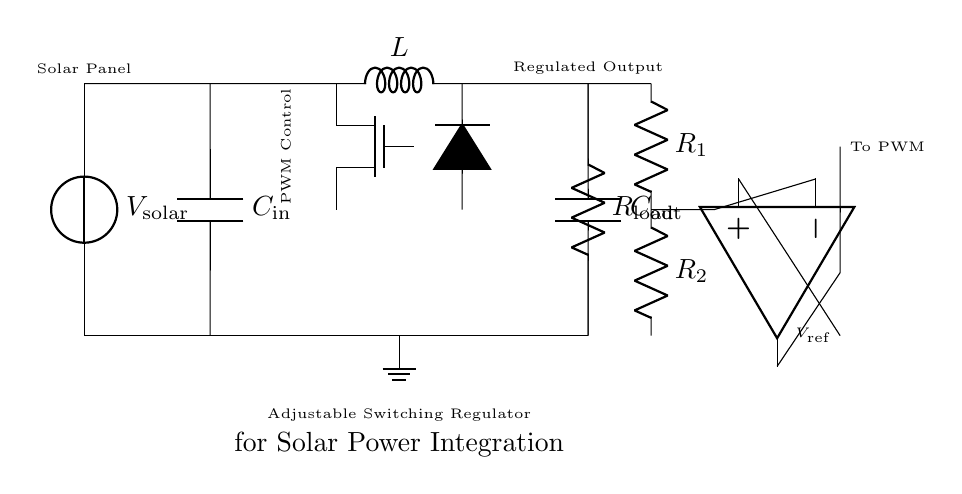What component is used for energy storage in this circuit? The component primarily responsible for energy storage in this circuit is the inductor, as it stores energy in the magnetic field when current flows through it.
Answer: Inductor What does the capacitor labeled C_in do? The capacitor labeled C_in smooths the voltage from the solar panel by filtering any voltage spikes or fluctuations, providing a more stable input for the regulator.
Answer: Smooths voltage What is the role of the MOSFET in this regulator circuit? The MOSFET acts as a switch that regulates the power delivered to the output by rapidly turning on and off based on the PWM control signal, thus adjusting the output voltage.
Answer: Regulates power How many resistors are in the feedback network? There are two resistors in the feedback network, labeled R_1 and R_2, which form a voltage divider that helps control the feedback to the PWM control.
Answer: Two What does the output capacitor C_out do? The output capacitor C_out filters the output voltage and maintains a steady voltage level at the load by smoothing out any fluctuations caused by varying load conditions.
Answer: Filters output voltage What is provided as feedback to the PWM control circuit? Feedback is provided as the output voltage from the load via the voltage divider formed by R_1 and R_2, allowing the PWM control to adjust the MOSFET operation based on the output voltage level.
Answer: Output voltage 